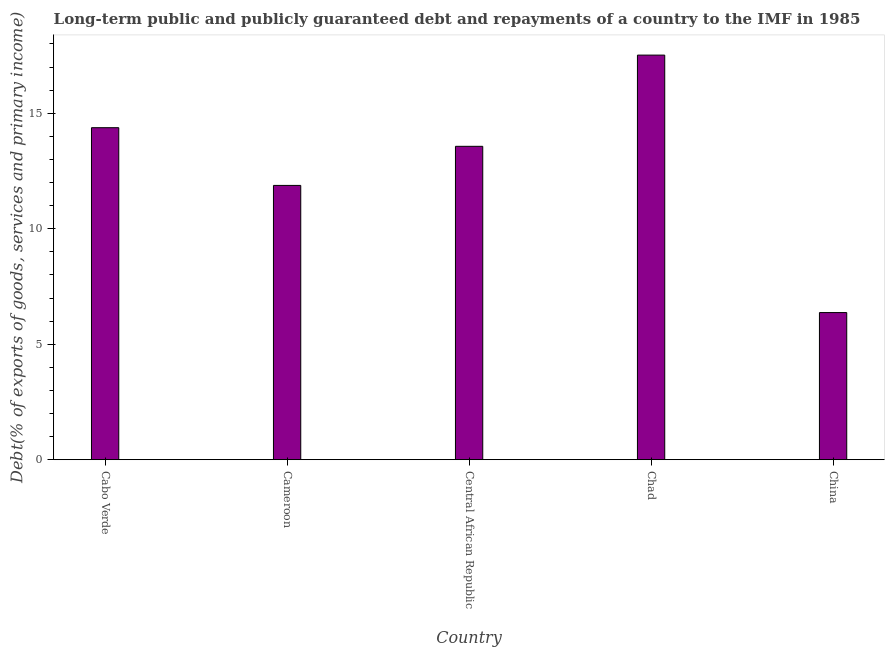Does the graph contain any zero values?
Offer a very short reply. No. Does the graph contain grids?
Make the answer very short. No. What is the title of the graph?
Your answer should be very brief. Long-term public and publicly guaranteed debt and repayments of a country to the IMF in 1985. What is the label or title of the Y-axis?
Keep it short and to the point. Debt(% of exports of goods, services and primary income). What is the debt service in Cabo Verde?
Offer a terse response. 14.37. Across all countries, what is the maximum debt service?
Make the answer very short. 17.52. Across all countries, what is the minimum debt service?
Make the answer very short. 6.37. In which country was the debt service maximum?
Offer a terse response. Chad. What is the sum of the debt service?
Keep it short and to the point. 63.71. What is the difference between the debt service in Central African Republic and China?
Ensure brevity in your answer.  7.2. What is the average debt service per country?
Keep it short and to the point. 12.74. What is the median debt service?
Provide a short and direct response. 13.57. What is the ratio of the debt service in Central African Republic to that in China?
Offer a very short reply. 2.13. Is the debt service in Chad less than that in China?
Ensure brevity in your answer.  No. What is the difference between the highest and the second highest debt service?
Offer a very short reply. 3.14. Is the sum of the debt service in Central African Republic and Chad greater than the maximum debt service across all countries?
Ensure brevity in your answer.  Yes. What is the difference between the highest and the lowest debt service?
Make the answer very short. 11.15. In how many countries, is the debt service greater than the average debt service taken over all countries?
Your answer should be very brief. 3. How many bars are there?
Ensure brevity in your answer.  5. Are all the bars in the graph horizontal?
Keep it short and to the point. No. What is the difference between two consecutive major ticks on the Y-axis?
Ensure brevity in your answer.  5. What is the Debt(% of exports of goods, services and primary income) of Cabo Verde?
Offer a terse response. 14.37. What is the Debt(% of exports of goods, services and primary income) in Cameroon?
Give a very brief answer. 11.88. What is the Debt(% of exports of goods, services and primary income) of Central African Republic?
Offer a very short reply. 13.57. What is the Debt(% of exports of goods, services and primary income) of Chad?
Your answer should be very brief. 17.52. What is the Debt(% of exports of goods, services and primary income) of China?
Offer a very short reply. 6.37. What is the difference between the Debt(% of exports of goods, services and primary income) in Cabo Verde and Cameroon?
Your answer should be compact. 2.5. What is the difference between the Debt(% of exports of goods, services and primary income) in Cabo Verde and Central African Republic?
Ensure brevity in your answer.  0.81. What is the difference between the Debt(% of exports of goods, services and primary income) in Cabo Verde and Chad?
Offer a terse response. -3.14. What is the difference between the Debt(% of exports of goods, services and primary income) in Cabo Verde and China?
Keep it short and to the point. 8. What is the difference between the Debt(% of exports of goods, services and primary income) in Cameroon and Central African Republic?
Your answer should be very brief. -1.69. What is the difference between the Debt(% of exports of goods, services and primary income) in Cameroon and Chad?
Provide a succinct answer. -5.64. What is the difference between the Debt(% of exports of goods, services and primary income) in Cameroon and China?
Offer a very short reply. 5.51. What is the difference between the Debt(% of exports of goods, services and primary income) in Central African Republic and Chad?
Keep it short and to the point. -3.95. What is the difference between the Debt(% of exports of goods, services and primary income) in Central African Republic and China?
Offer a very short reply. 7.2. What is the difference between the Debt(% of exports of goods, services and primary income) in Chad and China?
Make the answer very short. 11.15. What is the ratio of the Debt(% of exports of goods, services and primary income) in Cabo Verde to that in Cameroon?
Give a very brief answer. 1.21. What is the ratio of the Debt(% of exports of goods, services and primary income) in Cabo Verde to that in Central African Republic?
Keep it short and to the point. 1.06. What is the ratio of the Debt(% of exports of goods, services and primary income) in Cabo Verde to that in Chad?
Offer a terse response. 0.82. What is the ratio of the Debt(% of exports of goods, services and primary income) in Cabo Verde to that in China?
Keep it short and to the point. 2.26. What is the ratio of the Debt(% of exports of goods, services and primary income) in Cameroon to that in Chad?
Make the answer very short. 0.68. What is the ratio of the Debt(% of exports of goods, services and primary income) in Cameroon to that in China?
Your answer should be very brief. 1.86. What is the ratio of the Debt(% of exports of goods, services and primary income) in Central African Republic to that in Chad?
Your answer should be very brief. 0.78. What is the ratio of the Debt(% of exports of goods, services and primary income) in Central African Republic to that in China?
Your answer should be very brief. 2.13. What is the ratio of the Debt(% of exports of goods, services and primary income) in Chad to that in China?
Make the answer very short. 2.75. 